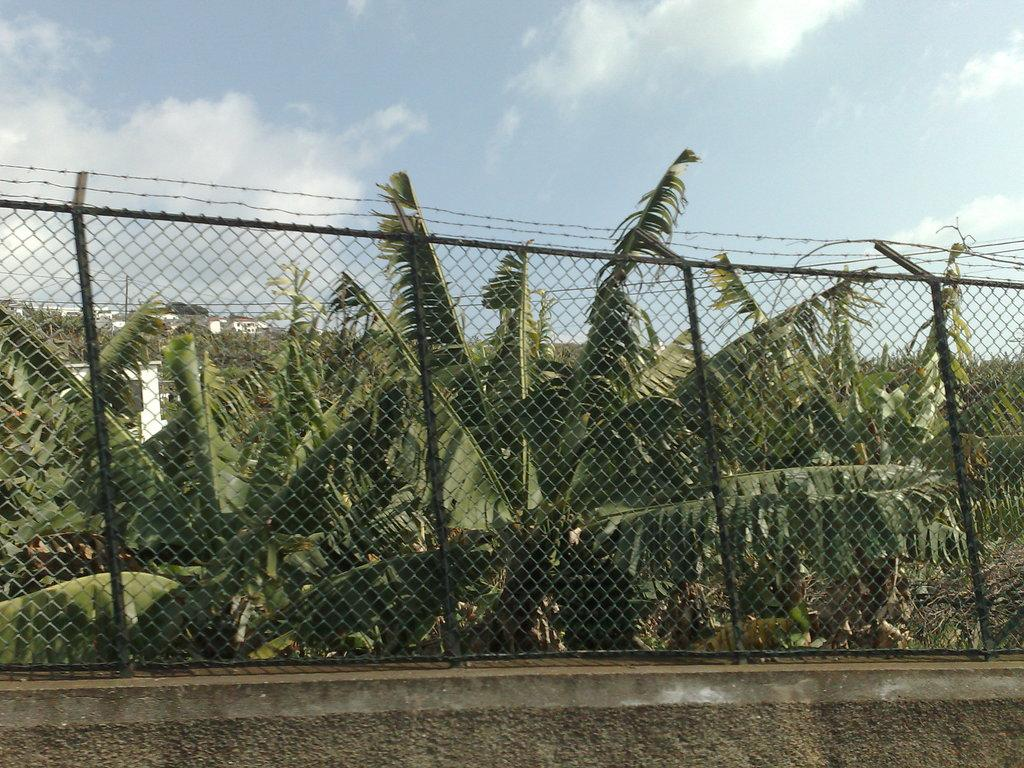What is located in the center of the image? There is a fence in the center of the image. What type of vegetation can be seen in the image? There are trees in the image. What structures are visible in the background of the image? There are sheds in the background of the image. What is visible in the background of the image besides the sheds? The sky is visible in the background of the image. What is at the bottom of the image? There is a wall at the bottom of the image. What is the weight of the moon in the image? There is no moon present in the image, so it is not possible to determine its weight. 